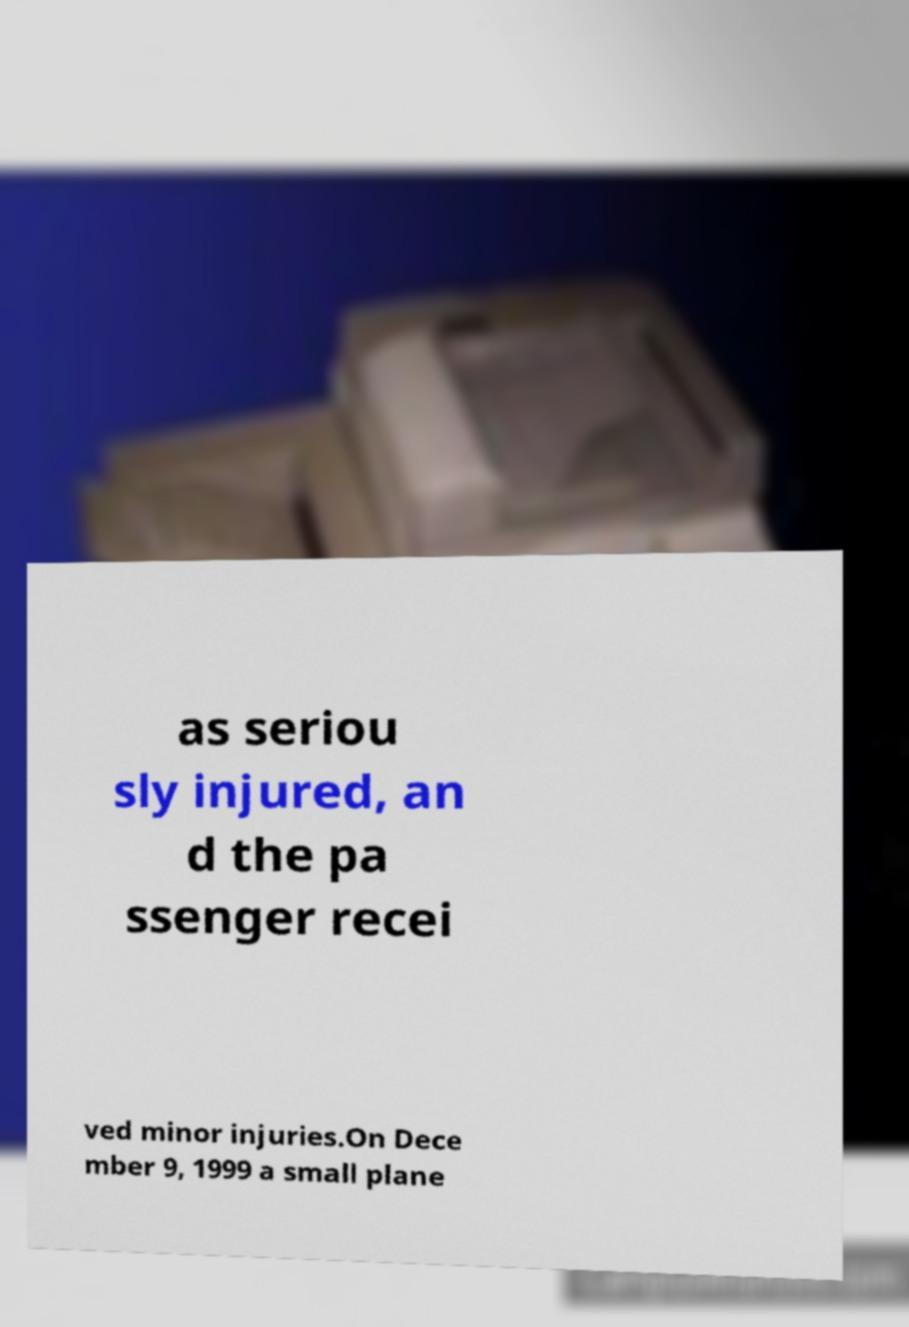Could you assist in decoding the text presented in this image and type it out clearly? as seriou sly injured, an d the pa ssenger recei ved minor injuries.On Dece mber 9, 1999 a small plane 